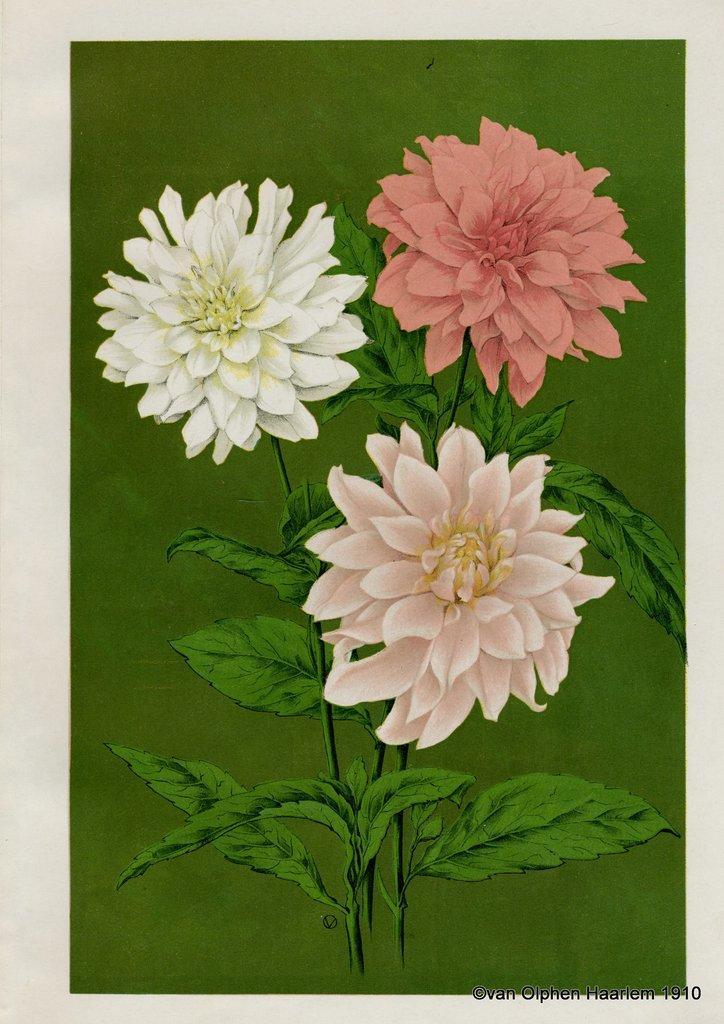How would you summarize this image in a sentence or two? In this picture I can see a painting of a plant with flowers, and there is a watermark on the image. 